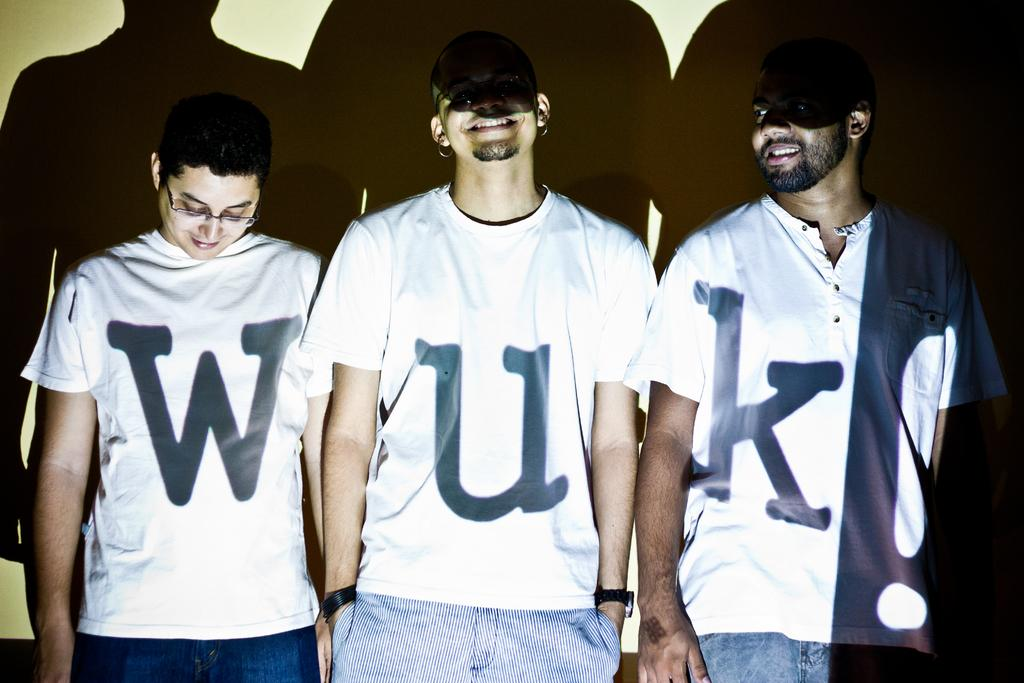<image>
Present a compact description of the photo's key features. Three men stand close together wearing white T-shirts with the letters "Wuk!" projected on them. 